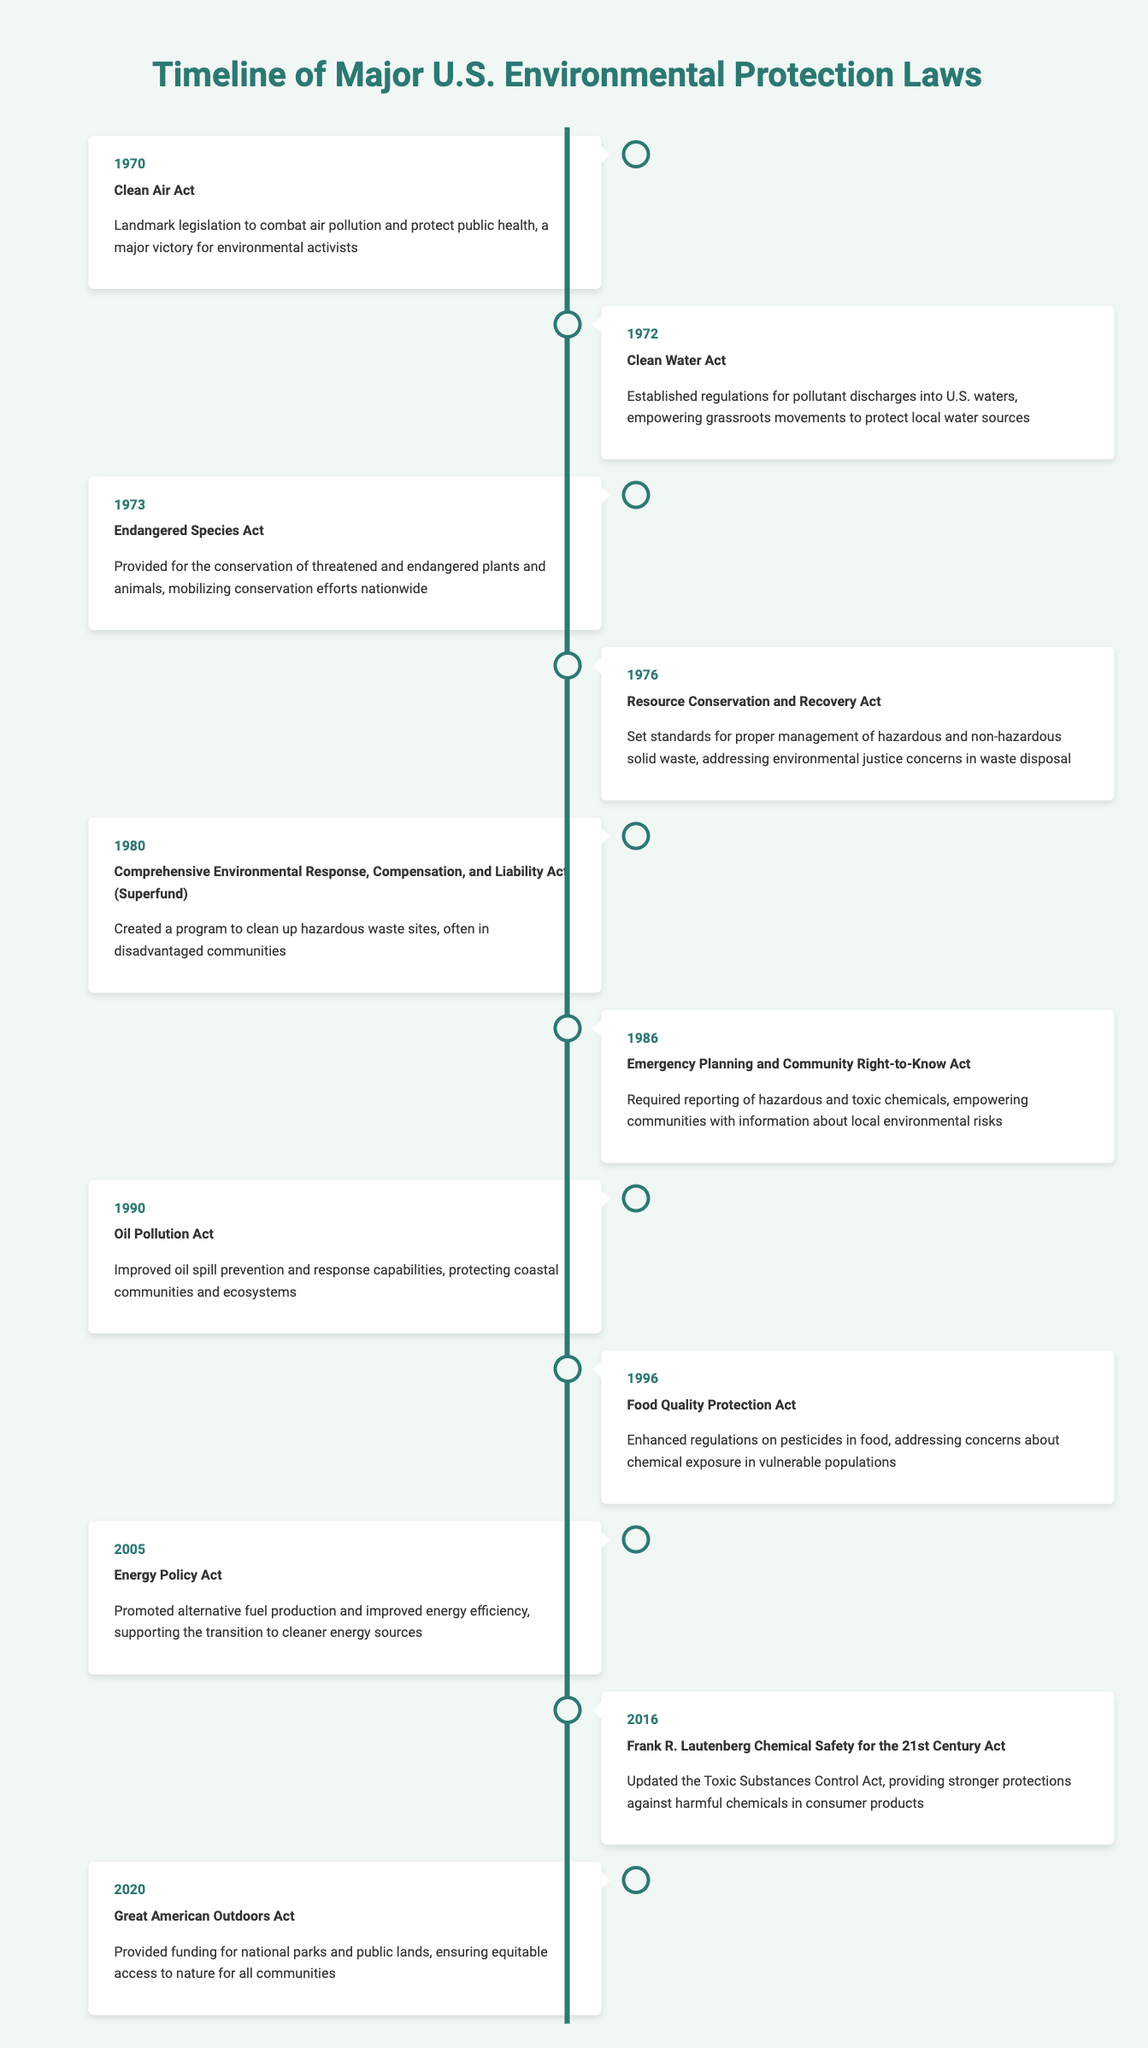What year was the Clean Air Act passed? The Clean Air Act is listed in the timeline for the year 1970.
Answer: 1970 What event in 1990 aimed to improve oil spill prevention? The event listed for 1990 is the Oil Pollution Act, which focuses on improving oil spill prevention and response capabilities.
Answer: Oil Pollution Act How many years are there between the passing of the Clean Water Act and the Endangered Species Act? The Clean Water Act was passed in 1972 and the Endangered Species Act in 1973. The difference is 1 year (1973 - 1972).
Answer: 1 year Was the Resource Conservation and Recovery Act passed before or after the Oil Pollution Act? The Resource Conservation and Recovery Act was passed in 1976 and the Oil Pollution Act in 1990. Since 1976 is before 1990, this statement is true.
Answer: Yes What is the most recent law listed on the timeline? The timeline ends with the Great American Outdoors Act, which was enacted in 2020, making it the most recent law listed.
Answer: Great American Outdoors Act Which two laws focus on community safety and awareness about hazardous substances? The Emergency Planning and Community Right-to-Know Act (1986) requires reporting of hazardous substances, and the Frank R. Lautenberg Chemical Safety for the 21st Century Act (2016) updates protections against harmful chemicals. Both involve community safety and awareness about hazardous substances.
Answer: Emergency Planning and Community Right-to-Know Act and Frank R. Lautenberg Chemical Safety for the 21st Century Act What percentage of the listed laws deal with air or water protection? There are 11 laws total. The Clean Air Act and Clean Water Act are the only two focused on air and water protection, which translates to (2/11) * 100, yielding approximately 18.18%.
Answer: Approximately 18.18% Identify the legislation that created a program to clean up hazardous waste sites. The Comprehensive Environmental Response, Compensation, and Liability Act, often called Superfund, created a program for cleaning up hazardous waste sites, particularly in disadvantaged communities.
Answer: Comprehensive Environmental Response, Compensation, and Liability Act How many laws were enacted in the 1970s compared to the 1980s? In the 1970s, there were 4 laws (1970, 1972, 1973, 1976) enacted compared to 3 laws in the 1980s (1980, 1986). This shows that more legislation was passed in the 1970s than the 1980s.
Answer: 4 in the 1970s, 3 in the 1980s 